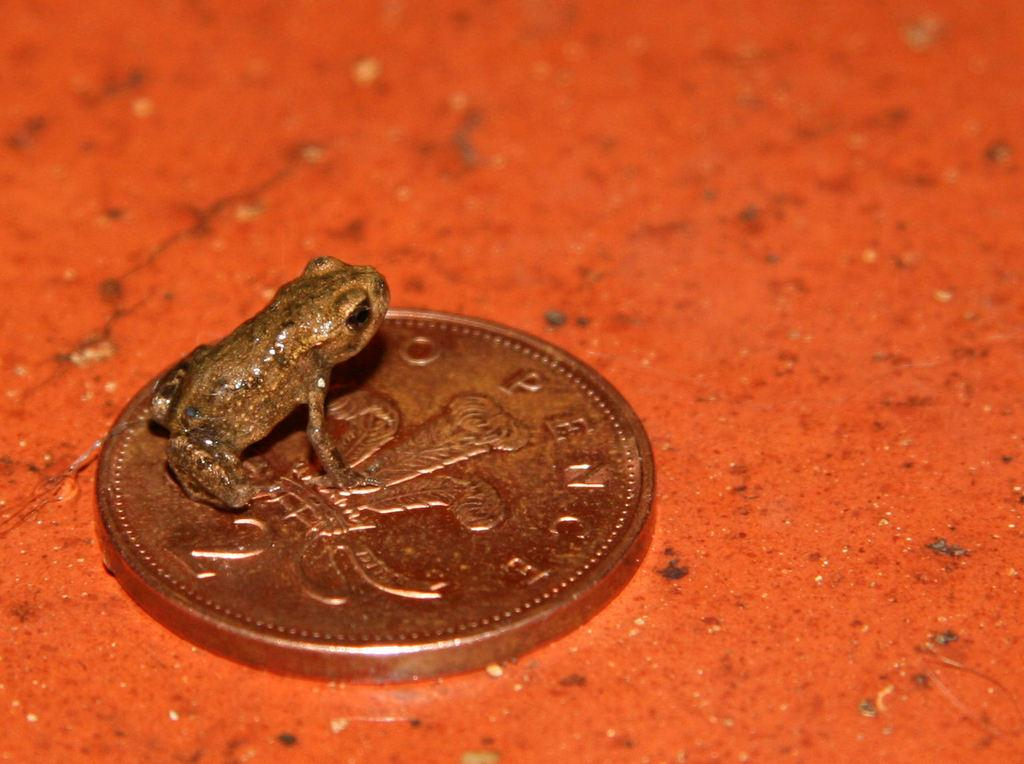What object is present in the image? There is a coin in the image. What is the color of the surface on which the coin is placed? The coin is on a red surface. What additional element is present on the coin? There is a frog on the coin. Can you hear the yarn being knitted in the image? There is no yarn or knitting activity present in the image. Is the frog taking a bath on the coin in the image? There is no indication of a bath or any water-related activity in the image. 